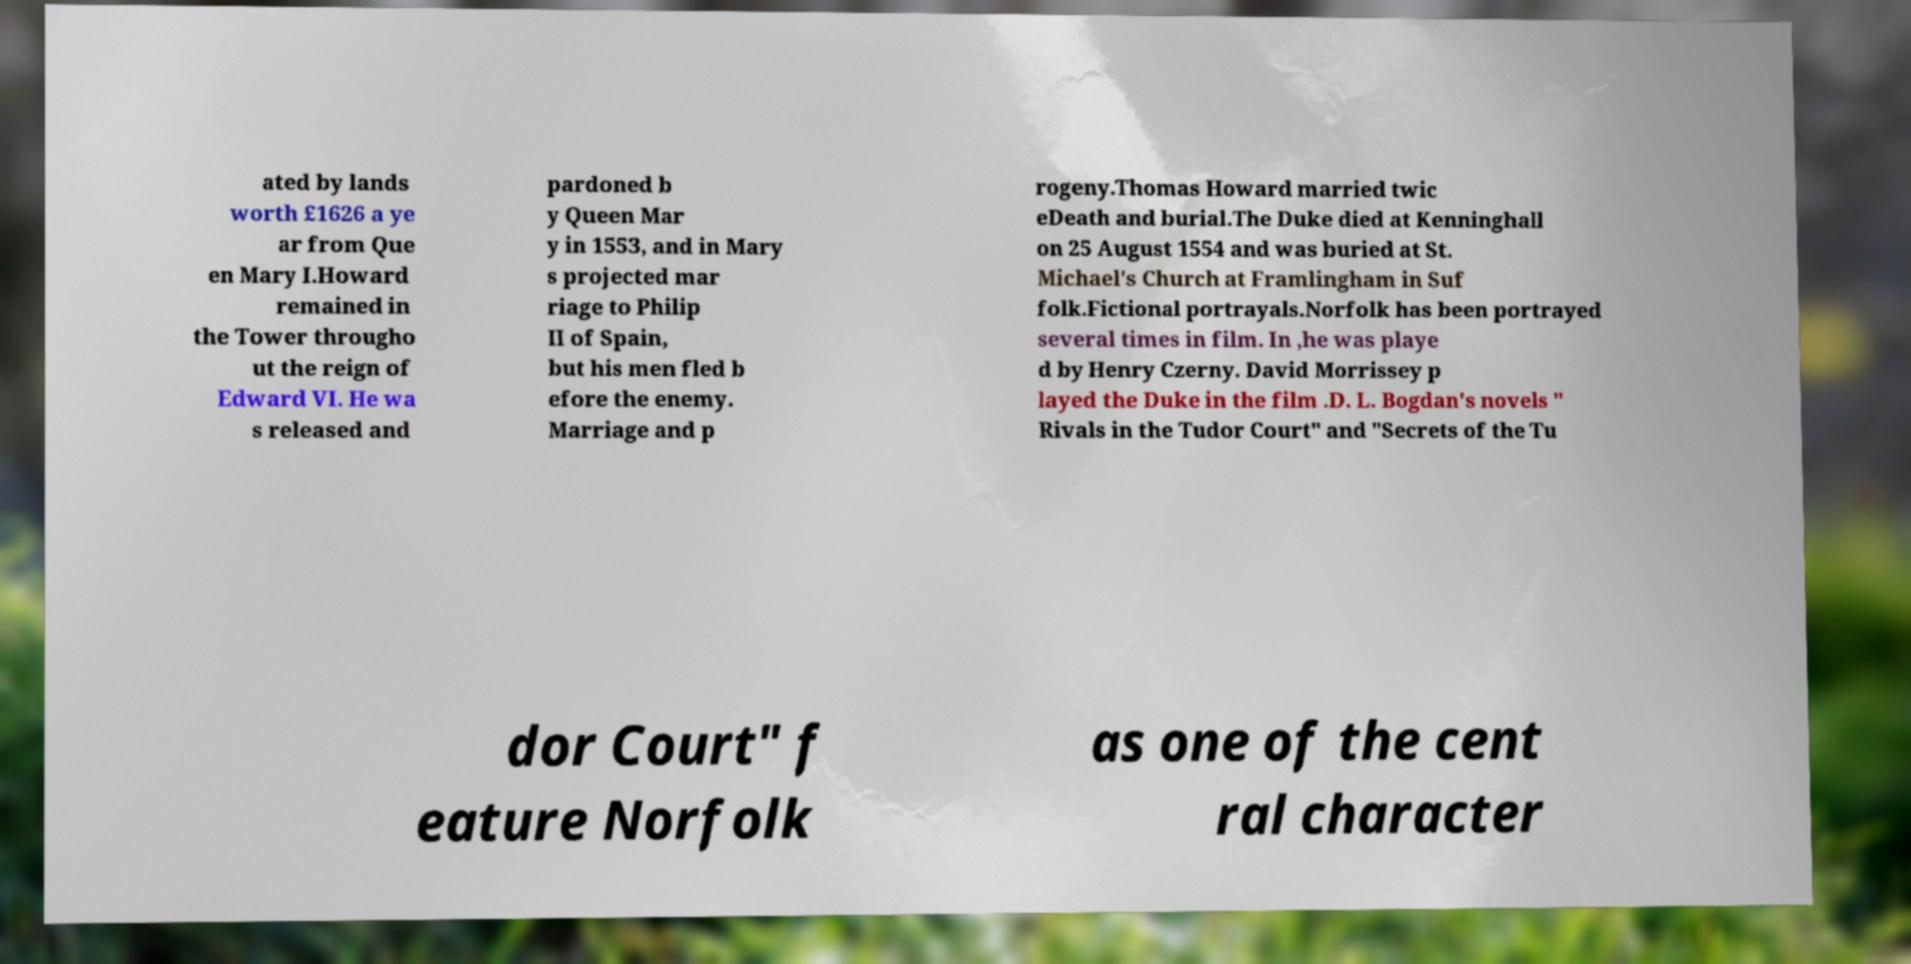What messages or text are displayed in this image? I need them in a readable, typed format. ated by lands worth £1626 a ye ar from Que en Mary I.Howard remained in the Tower througho ut the reign of Edward VI. He wa s released and pardoned b y Queen Mar y in 1553, and in Mary s projected mar riage to Philip II of Spain, but his men fled b efore the enemy. Marriage and p rogeny.Thomas Howard married twic eDeath and burial.The Duke died at Kenninghall on 25 August 1554 and was buried at St. Michael's Church at Framlingham in Suf folk.Fictional portrayals.Norfolk has been portrayed several times in film. In ,he was playe d by Henry Czerny. David Morrissey p layed the Duke in the film .D. L. Bogdan's novels " Rivals in the Tudor Court" and "Secrets of the Tu dor Court" f eature Norfolk as one of the cent ral character 